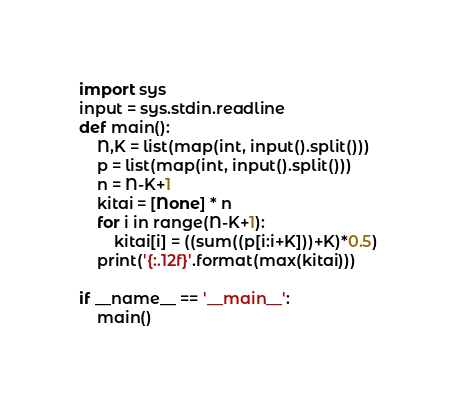<code> <loc_0><loc_0><loc_500><loc_500><_Python_>import sys
input = sys.stdin.readline
def main():
    N,K = list(map(int, input().split()))
    p = list(map(int, input().split()))
    n = N-K+1
    kitai = [None] * n
    for i in range(N-K+1):
        kitai[i] = ((sum((p[i:i+K]))+K)*0.5)
    print('{:.12f}'.format(max(kitai)))

if __name__ == '__main__':
    main()
</code> 